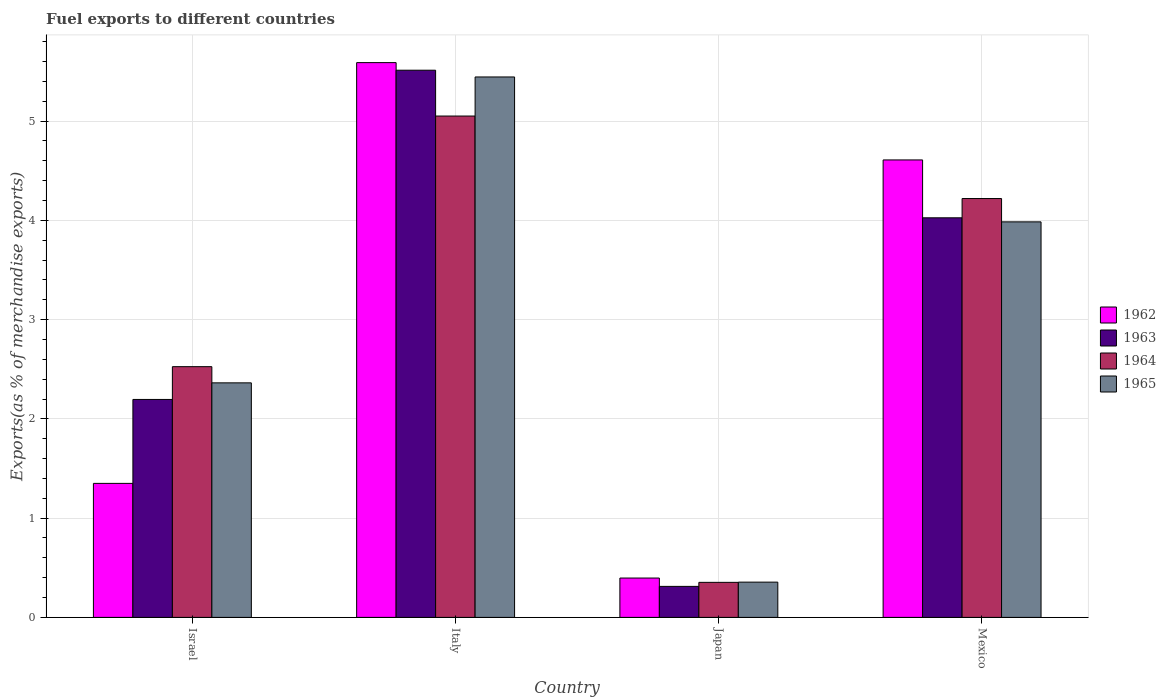Are the number of bars per tick equal to the number of legend labels?
Your answer should be very brief. Yes. How many bars are there on the 2nd tick from the left?
Give a very brief answer. 4. In how many cases, is the number of bars for a given country not equal to the number of legend labels?
Offer a terse response. 0. What is the percentage of exports to different countries in 1962 in Japan?
Provide a short and direct response. 0.4. Across all countries, what is the maximum percentage of exports to different countries in 1965?
Provide a short and direct response. 5.45. Across all countries, what is the minimum percentage of exports to different countries in 1964?
Your answer should be very brief. 0.35. In which country was the percentage of exports to different countries in 1962 maximum?
Offer a very short reply. Italy. In which country was the percentage of exports to different countries in 1965 minimum?
Offer a terse response. Japan. What is the total percentage of exports to different countries in 1965 in the graph?
Offer a very short reply. 12.15. What is the difference between the percentage of exports to different countries in 1964 in Italy and that in Mexico?
Give a very brief answer. 0.83. What is the difference between the percentage of exports to different countries in 1962 in Japan and the percentage of exports to different countries in 1963 in Italy?
Ensure brevity in your answer.  -5.12. What is the average percentage of exports to different countries in 1962 per country?
Provide a succinct answer. 2.99. What is the difference between the percentage of exports to different countries of/in 1963 and percentage of exports to different countries of/in 1965 in Israel?
Keep it short and to the point. -0.17. In how many countries, is the percentage of exports to different countries in 1962 greater than 4.6 %?
Your answer should be very brief. 2. What is the ratio of the percentage of exports to different countries in 1963 in Israel to that in Italy?
Provide a short and direct response. 0.4. Is the difference between the percentage of exports to different countries in 1963 in Israel and Japan greater than the difference between the percentage of exports to different countries in 1965 in Israel and Japan?
Offer a very short reply. No. What is the difference between the highest and the second highest percentage of exports to different countries in 1964?
Your response must be concise. -1.69. What is the difference between the highest and the lowest percentage of exports to different countries in 1963?
Offer a very short reply. 5.2. Is the sum of the percentage of exports to different countries in 1963 in Israel and Mexico greater than the maximum percentage of exports to different countries in 1965 across all countries?
Provide a succinct answer. Yes. Are all the bars in the graph horizontal?
Provide a short and direct response. No. Does the graph contain any zero values?
Your answer should be compact. No. Does the graph contain grids?
Offer a terse response. Yes. What is the title of the graph?
Ensure brevity in your answer.  Fuel exports to different countries. Does "1990" appear as one of the legend labels in the graph?
Offer a very short reply. No. What is the label or title of the X-axis?
Provide a succinct answer. Country. What is the label or title of the Y-axis?
Give a very brief answer. Exports(as % of merchandise exports). What is the Exports(as % of merchandise exports) of 1962 in Israel?
Offer a very short reply. 1.35. What is the Exports(as % of merchandise exports) of 1963 in Israel?
Offer a terse response. 2.2. What is the Exports(as % of merchandise exports) in 1964 in Israel?
Provide a succinct answer. 2.53. What is the Exports(as % of merchandise exports) of 1965 in Israel?
Your response must be concise. 2.36. What is the Exports(as % of merchandise exports) in 1962 in Italy?
Your response must be concise. 5.59. What is the Exports(as % of merchandise exports) of 1963 in Italy?
Offer a very short reply. 5.51. What is the Exports(as % of merchandise exports) in 1964 in Italy?
Ensure brevity in your answer.  5.05. What is the Exports(as % of merchandise exports) of 1965 in Italy?
Keep it short and to the point. 5.45. What is the Exports(as % of merchandise exports) in 1962 in Japan?
Offer a terse response. 0.4. What is the Exports(as % of merchandise exports) in 1963 in Japan?
Offer a very short reply. 0.31. What is the Exports(as % of merchandise exports) in 1964 in Japan?
Provide a short and direct response. 0.35. What is the Exports(as % of merchandise exports) in 1965 in Japan?
Provide a short and direct response. 0.36. What is the Exports(as % of merchandise exports) of 1962 in Mexico?
Your answer should be very brief. 4.61. What is the Exports(as % of merchandise exports) of 1963 in Mexico?
Your answer should be compact. 4.03. What is the Exports(as % of merchandise exports) in 1964 in Mexico?
Give a very brief answer. 4.22. What is the Exports(as % of merchandise exports) of 1965 in Mexico?
Keep it short and to the point. 3.99. Across all countries, what is the maximum Exports(as % of merchandise exports) in 1962?
Keep it short and to the point. 5.59. Across all countries, what is the maximum Exports(as % of merchandise exports) in 1963?
Your answer should be compact. 5.51. Across all countries, what is the maximum Exports(as % of merchandise exports) in 1964?
Your response must be concise. 5.05. Across all countries, what is the maximum Exports(as % of merchandise exports) in 1965?
Ensure brevity in your answer.  5.45. Across all countries, what is the minimum Exports(as % of merchandise exports) in 1962?
Offer a terse response. 0.4. Across all countries, what is the minimum Exports(as % of merchandise exports) in 1963?
Your answer should be compact. 0.31. Across all countries, what is the minimum Exports(as % of merchandise exports) of 1964?
Your answer should be very brief. 0.35. Across all countries, what is the minimum Exports(as % of merchandise exports) in 1965?
Ensure brevity in your answer.  0.36. What is the total Exports(as % of merchandise exports) in 1962 in the graph?
Give a very brief answer. 11.95. What is the total Exports(as % of merchandise exports) in 1963 in the graph?
Your response must be concise. 12.05. What is the total Exports(as % of merchandise exports) of 1964 in the graph?
Your answer should be very brief. 12.15. What is the total Exports(as % of merchandise exports) of 1965 in the graph?
Ensure brevity in your answer.  12.15. What is the difference between the Exports(as % of merchandise exports) in 1962 in Israel and that in Italy?
Your answer should be compact. -4.24. What is the difference between the Exports(as % of merchandise exports) of 1963 in Israel and that in Italy?
Provide a short and direct response. -3.32. What is the difference between the Exports(as % of merchandise exports) of 1964 in Israel and that in Italy?
Offer a terse response. -2.53. What is the difference between the Exports(as % of merchandise exports) of 1965 in Israel and that in Italy?
Your answer should be compact. -3.08. What is the difference between the Exports(as % of merchandise exports) of 1962 in Israel and that in Japan?
Keep it short and to the point. 0.95. What is the difference between the Exports(as % of merchandise exports) in 1963 in Israel and that in Japan?
Your answer should be very brief. 1.88. What is the difference between the Exports(as % of merchandise exports) of 1964 in Israel and that in Japan?
Make the answer very short. 2.17. What is the difference between the Exports(as % of merchandise exports) of 1965 in Israel and that in Japan?
Make the answer very short. 2.01. What is the difference between the Exports(as % of merchandise exports) of 1962 in Israel and that in Mexico?
Give a very brief answer. -3.26. What is the difference between the Exports(as % of merchandise exports) of 1963 in Israel and that in Mexico?
Give a very brief answer. -1.83. What is the difference between the Exports(as % of merchandise exports) of 1964 in Israel and that in Mexico?
Offer a very short reply. -1.69. What is the difference between the Exports(as % of merchandise exports) of 1965 in Israel and that in Mexico?
Give a very brief answer. -1.62. What is the difference between the Exports(as % of merchandise exports) in 1962 in Italy and that in Japan?
Your answer should be compact. 5.19. What is the difference between the Exports(as % of merchandise exports) in 1963 in Italy and that in Japan?
Offer a terse response. 5.2. What is the difference between the Exports(as % of merchandise exports) of 1964 in Italy and that in Japan?
Provide a short and direct response. 4.7. What is the difference between the Exports(as % of merchandise exports) in 1965 in Italy and that in Japan?
Keep it short and to the point. 5.09. What is the difference between the Exports(as % of merchandise exports) in 1962 in Italy and that in Mexico?
Offer a terse response. 0.98. What is the difference between the Exports(as % of merchandise exports) of 1963 in Italy and that in Mexico?
Your answer should be very brief. 1.49. What is the difference between the Exports(as % of merchandise exports) of 1964 in Italy and that in Mexico?
Offer a very short reply. 0.83. What is the difference between the Exports(as % of merchandise exports) in 1965 in Italy and that in Mexico?
Provide a short and direct response. 1.46. What is the difference between the Exports(as % of merchandise exports) of 1962 in Japan and that in Mexico?
Offer a very short reply. -4.21. What is the difference between the Exports(as % of merchandise exports) in 1963 in Japan and that in Mexico?
Ensure brevity in your answer.  -3.71. What is the difference between the Exports(as % of merchandise exports) of 1964 in Japan and that in Mexico?
Make the answer very short. -3.87. What is the difference between the Exports(as % of merchandise exports) of 1965 in Japan and that in Mexico?
Offer a terse response. -3.63. What is the difference between the Exports(as % of merchandise exports) of 1962 in Israel and the Exports(as % of merchandise exports) of 1963 in Italy?
Your answer should be compact. -4.16. What is the difference between the Exports(as % of merchandise exports) of 1962 in Israel and the Exports(as % of merchandise exports) of 1964 in Italy?
Provide a short and direct response. -3.7. What is the difference between the Exports(as % of merchandise exports) in 1962 in Israel and the Exports(as % of merchandise exports) in 1965 in Italy?
Keep it short and to the point. -4.09. What is the difference between the Exports(as % of merchandise exports) in 1963 in Israel and the Exports(as % of merchandise exports) in 1964 in Italy?
Your response must be concise. -2.86. What is the difference between the Exports(as % of merchandise exports) in 1963 in Israel and the Exports(as % of merchandise exports) in 1965 in Italy?
Your response must be concise. -3.25. What is the difference between the Exports(as % of merchandise exports) in 1964 in Israel and the Exports(as % of merchandise exports) in 1965 in Italy?
Keep it short and to the point. -2.92. What is the difference between the Exports(as % of merchandise exports) of 1962 in Israel and the Exports(as % of merchandise exports) of 1963 in Japan?
Offer a very short reply. 1.04. What is the difference between the Exports(as % of merchandise exports) in 1962 in Israel and the Exports(as % of merchandise exports) in 1965 in Japan?
Offer a very short reply. 0.99. What is the difference between the Exports(as % of merchandise exports) in 1963 in Israel and the Exports(as % of merchandise exports) in 1964 in Japan?
Offer a terse response. 1.84. What is the difference between the Exports(as % of merchandise exports) in 1963 in Israel and the Exports(as % of merchandise exports) in 1965 in Japan?
Your answer should be very brief. 1.84. What is the difference between the Exports(as % of merchandise exports) in 1964 in Israel and the Exports(as % of merchandise exports) in 1965 in Japan?
Provide a short and direct response. 2.17. What is the difference between the Exports(as % of merchandise exports) in 1962 in Israel and the Exports(as % of merchandise exports) in 1963 in Mexico?
Your answer should be very brief. -2.68. What is the difference between the Exports(as % of merchandise exports) of 1962 in Israel and the Exports(as % of merchandise exports) of 1964 in Mexico?
Offer a very short reply. -2.87. What is the difference between the Exports(as % of merchandise exports) in 1962 in Israel and the Exports(as % of merchandise exports) in 1965 in Mexico?
Offer a very short reply. -2.63. What is the difference between the Exports(as % of merchandise exports) in 1963 in Israel and the Exports(as % of merchandise exports) in 1964 in Mexico?
Your answer should be very brief. -2.02. What is the difference between the Exports(as % of merchandise exports) in 1963 in Israel and the Exports(as % of merchandise exports) in 1965 in Mexico?
Your response must be concise. -1.79. What is the difference between the Exports(as % of merchandise exports) of 1964 in Israel and the Exports(as % of merchandise exports) of 1965 in Mexico?
Ensure brevity in your answer.  -1.46. What is the difference between the Exports(as % of merchandise exports) in 1962 in Italy and the Exports(as % of merchandise exports) in 1963 in Japan?
Your answer should be compact. 5.28. What is the difference between the Exports(as % of merchandise exports) of 1962 in Italy and the Exports(as % of merchandise exports) of 1964 in Japan?
Provide a short and direct response. 5.24. What is the difference between the Exports(as % of merchandise exports) of 1962 in Italy and the Exports(as % of merchandise exports) of 1965 in Japan?
Make the answer very short. 5.23. What is the difference between the Exports(as % of merchandise exports) of 1963 in Italy and the Exports(as % of merchandise exports) of 1964 in Japan?
Offer a very short reply. 5.16. What is the difference between the Exports(as % of merchandise exports) in 1963 in Italy and the Exports(as % of merchandise exports) in 1965 in Japan?
Keep it short and to the point. 5.16. What is the difference between the Exports(as % of merchandise exports) in 1964 in Italy and the Exports(as % of merchandise exports) in 1965 in Japan?
Provide a succinct answer. 4.7. What is the difference between the Exports(as % of merchandise exports) in 1962 in Italy and the Exports(as % of merchandise exports) in 1963 in Mexico?
Offer a terse response. 1.56. What is the difference between the Exports(as % of merchandise exports) of 1962 in Italy and the Exports(as % of merchandise exports) of 1964 in Mexico?
Give a very brief answer. 1.37. What is the difference between the Exports(as % of merchandise exports) in 1962 in Italy and the Exports(as % of merchandise exports) in 1965 in Mexico?
Offer a terse response. 1.6. What is the difference between the Exports(as % of merchandise exports) of 1963 in Italy and the Exports(as % of merchandise exports) of 1964 in Mexico?
Your answer should be compact. 1.29. What is the difference between the Exports(as % of merchandise exports) in 1963 in Italy and the Exports(as % of merchandise exports) in 1965 in Mexico?
Provide a succinct answer. 1.53. What is the difference between the Exports(as % of merchandise exports) of 1964 in Italy and the Exports(as % of merchandise exports) of 1965 in Mexico?
Ensure brevity in your answer.  1.07. What is the difference between the Exports(as % of merchandise exports) in 1962 in Japan and the Exports(as % of merchandise exports) in 1963 in Mexico?
Your answer should be compact. -3.63. What is the difference between the Exports(as % of merchandise exports) in 1962 in Japan and the Exports(as % of merchandise exports) in 1964 in Mexico?
Provide a succinct answer. -3.82. What is the difference between the Exports(as % of merchandise exports) of 1962 in Japan and the Exports(as % of merchandise exports) of 1965 in Mexico?
Keep it short and to the point. -3.59. What is the difference between the Exports(as % of merchandise exports) of 1963 in Japan and the Exports(as % of merchandise exports) of 1964 in Mexico?
Make the answer very short. -3.91. What is the difference between the Exports(as % of merchandise exports) in 1963 in Japan and the Exports(as % of merchandise exports) in 1965 in Mexico?
Your answer should be compact. -3.67. What is the difference between the Exports(as % of merchandise exports) in 1964 in Japan and the Exports(as % of merchandise exports) in 1965 in Mexico?
Ensure brevity in your answer.  -3.63. What is the average Exports(as % of merchandise exports) in 1962 per country?
Give a very brief answer. 2.99. What is the average Exports(as % of merchandise exports) in 1963 per country?
Keep it short and to the point. 3.01. What is the average Exports(as % of merchandise exports) of 1964 per country?
Ensure brevity in your answer.  3.04. What is the average Exports(as % of merchandise exports) of 1965 per country?
Make the answer very short. 3.04. What is the difference between the Exports(as % of merchandise exports) of 1962 and Exports(as % of merchandise exports) of 1963 in Israel?
Make the answer very short. -0.85. What is the difference between the Exports(as % of merchandise exports) of 1962 and Exports(as % of merchandise exports) of 1964 in Israel?
Offer a terse response. -1.18. What is the difference between the Exports(as % of merchandise exports) of 1962 and Exports(as % of merchandise exports) of 1965 in Israel?
Provide a succinct answer. -1.01. What is the difference between the Exports(as % of merchandise exports) in 1963 and Exports(as % of merchandise exports) in 1964 in Israel?
Give a very brief answer. -0.33. What is the difference between the Exports(as % of merchandise exports) in 1963 and Exports(as % of merchandise exports) in 1965 in Israel?
Give a very brief answer. -0.17. What is the difference between the Exports(as % of merchandise exports) of 1964 and Exports(as % of merchandise exports) of 1965 in Israel?
Your answer should be very brief. 0.16. What is the difference between the Exports(as % of merchandise exports) in 1962 and Exports(as % of merchandise exports) in 1963 in Italy?
Your answer should be very brief. 0.08. What is the difference between the Exports(as % of merchandise exports) in 1962 and Exports(as % of merchandise exports) in 1964 in Italy?
Offer a very short reply. 0.54. What is the difference between the Exports(as % of merchandise exports) in 1962 and Exports(as % of merchandise exports) in 1965 in Italy?
Your answer should be very brief. 0.14. What is the difference between the Exports(as % of merchandise exports) in 1963 and Exports(as % of merchandise exports) in 1964 in Italy?
Give a very brief answer. 0.46. What is the difference between the Exports(as % of merchandise exports) in 1963 and Exports(as % of merchandise exports) in 1965 in Italy?
Provide a succinct answer. 0.07. What is the difference between the Exports(as % of merchandise exports) of 1964 and Exports(as % of merchandise exports) of 1965 in Italy?
Your answer should be compact. -0.39. What is the difference between the Exports(as % of merchandise exports) of 1962 and Exports(as % of merchandise exports) of 1963 in Japan?
Keep it short and to the point. 0.08. What is the difference between the Exports(as % of merchandise exports) of 1962 and Exports(as % of merchandise exports) of 1964 in Japan?
Provide a succinct answer. 0.04. What is the difference between the Exports(as % of merchandise exports) of 1962 and Exports(as % of merchandise exports) of 1965 in Japan?
Provide a succinct answer. 0.04. What is the difference between the Exports(as % of merchandise exports) of 1963 and Exports(as % of merchandise exports) of 1964 in Japan?
Make the answer very short. -0.04. What is the difference between the Exports(as % of merchandise exports) in 1963 and Exports(as % of merchandise exports) in 1965 in Japan?
Keep it short and to the point. -0.04. What is the difference between the Exports(as % of merchandise exports) in 1964 and Exports(as % of merchandise exports) in 1965 in Japan?
Provide a short and direct response. -0. What is the difference between the Exports(as % of merchandise exports) of 1962 and Exports(as % of merchandise exports) of 1963 in Mexico?
Give a very brief answer. 0.58. What is the difference between the Exports(as % of merchandise exports) in 1962 and Exports(as % of merchandise exports) in 1964 in Mexico?
Ensure brevity in your answer.  0.39. What is the difference between the Exports(as % of merchandise exports) of 1962 and Exports(as % of merchandise exports) of 1965 in Mexico?
Your answer should be very brief. 0.62. What is the difference between the Exports(as % of merchandise exports) of 1963 and Exports(as % of merchandise exports) of 1964 in Mexico?
Your answer should be very brief. -0.19. What is the difference between the Exports(as % of merchandise exports) of 1963 and Exports(as % of merchandise exports) of 1965 in Mexico?
Offer a terse response. 0.04. What is the difference between the Exports(as % of merchandise exports) of 1964 and Exports(as % of merchandise exports) of 1965 in Mexico?
Your answer should be compact. 0.23. What is the ratio of the Exports(as % of merchandise exports) in 1962 in Israel to that in Italy?
Give a very brief answer. 0.24. What is the ratio of the Exports(as % of merchandise exports) in 1963 in Israel to that in Italy?
Offer a terse response. 0.4. What is the ratio of the Exports(as % of merchandise exports) of 1964 in Israel to that in Italy?
Provide a succinct answer. 0.5. What is the ratio of the Exports(as % of merchandise exports) in 1965 in Israel to that in Italy?
Offer a terse response. 0.43. What is the ratio of the Exports(as % of merchandise exports) of 1962 in Israel to that in Japan?
Your response must be concise. 3.4. What is the ratio of the Exports(as % of merchandise exports) in 1963 in Israel to that in Japan?
Offer a very short reply. 7.03. What is the ratio of the Exports(as % of merchandise exports) in 1964 in Israel to that in Japan?
Give a very brief answer. 7.16. What is the ratio of the Exports(as % of merchandise exports) of 1965 in Israel to that in Japan?
Make the answer very short. 6.65. What is the ratio of the Exports(as % of merchandise exports) of 1962 in Israel to that in Mexico?
Provide a succinct answer. 0.29. What is the ratio of the Exports(as % of merchandise exports) in 1963 in Israel to that in Mexico?
Offer a terse response. 0.55. What is the ratio of the Exports(as % of merchandise exports) in 1964 in Israel to that in Mexico?
Your response must be concise. 0.6. What is the ratio of the Exports(as % of merchandise exports) of 1965 in Israel to that in Mexico?
Your answer should be very brief. 0.59. What is the ratio of the Exports(as % of merchandise exports) in 1962 in Italy to that in Japan?
Offer a terse response. 14.1. What is the ratio of the Exports(as % of merchandise exports) of 1963 in Italy to that in Japan?
Keep it short and to the point. 17.64. What is the ratio of the Exports(as % of merchandise exports) of 1964 in Italy to that in Japan?
Make the answer very short. 14.31. What is the ratio of the Exports(as % of merchandise exports) of 1965 in Italy to that in Japan?
Give a very brief answer. 15.32. What is the ratio of the Exports(as % of merchandise exports) in 1962 in Italy to that in Mexico?
Your answer should be compact. 1.21. What is the ratio of the Exports(as % of merchandise exports) in 1963 in Italy to that in Mexico?
Offer a very short reply. 1.37. What is the ratio of the Exports(as % of merchandise exports) in 1964 in Italy to that in Mexico?
Make the answer very short. 1.2. What is the ratio of the Exports(as % of merchandise exports) of 1965 in Italy to that in Mexico?
Ensure brevity in your answer.  1.37. What is the ratio of the Exports(as % of merchandise exports) of 1962 in Japan to that in Mexico?
Your response must be concise. 0.09. What is the ratio of the Exports(as % of merchandise exports) in 1963 in Japan to that in Mexico?
Keep it short and to the point. 0.08. What is the ratio of the Exports(as % of merchandise exports) in 1964 in Japan to that in Mexico?
Your response must be concise. 0.08. What is the ratio of the Exports(as % of merchandise exports) of 1965 in Japan to that in Mexico?
Ensure brevity in your answer.  0.09. What is the difference between the highest and the second highest Exports(as % of merchandise exports) in 1962?
Provide a short and direct response. 0.98. What is the difference between the highest and the second highest Exports(as % of merchandise exports) of 1963?
Provide a short and direct response. 1.49. What is the difference between the highest and the second highest Exports(as % of merchandise exports) of 1964?
Make the answer very short. 0.83. What is the difference between the highest and the second highest Exports(as % of merchandise exports) in 1965?
Ensure brevity in your answer.  1.46. What is the difference between the highest and the lowest Exports(as % of merchandise exports) in 1962?
Ensure brevity in your answer.  5.19. What is the difference between the highest and the lowest Exports(as % of merchandise exports) in 1963?
Keep it short and to the point. 5.2. What is the difference between the highest and the lowest Exports(as % of merchandise exports) of 1964?
Your response must be concise. 4.7. What is the difference between the highest and the lowest Exports(as % of merchandise exports) in 1965?
Make the answer very short. 5.09. 